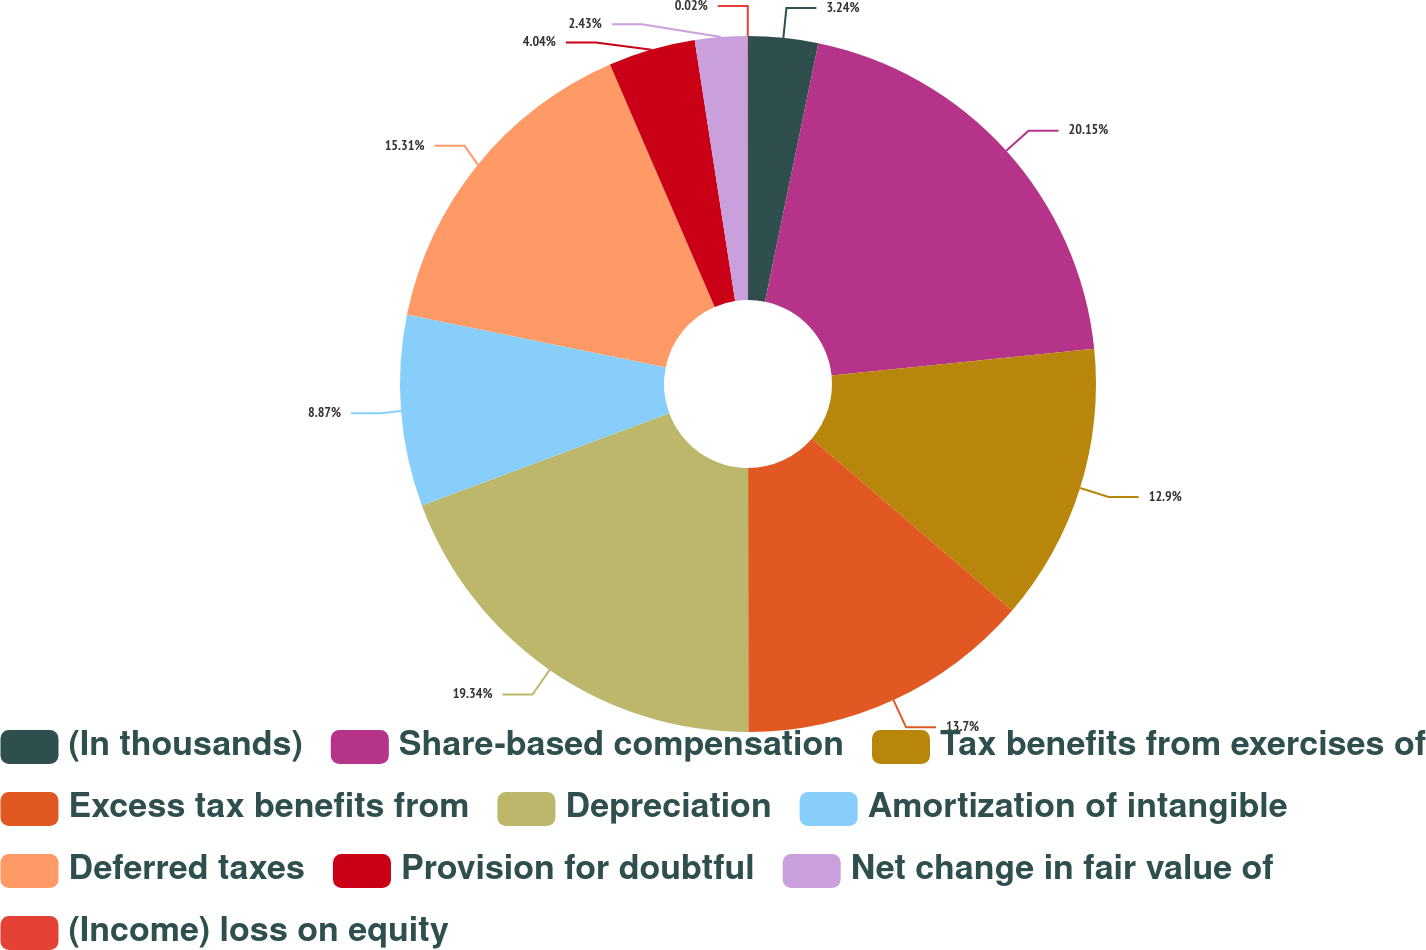Convert chart. <chart><loc_0><loc_0><loc_500><loc_500><pie_chart><fcel>(In thousands)<fcel>Share-based compensation<fcel>Tax benefits from exercises of<fcel>Excess tax benefits from<fcel>Depreciation<fcel>Amortization of intangible<fcel>Deferred taxes<fcel>Provision for doubtful<fcel>Net change in fair value of<fcel>(Income) loss on equity<nl><fcel>3.24%<fcel>20.14%<fcel>12.9%<fcel>13.7%<fcel>19.34%<fcel>8.87%<fcel>15.31%<fcel>4.04%<fcel>2.43%<fcel>0.02%<nl></chart> 